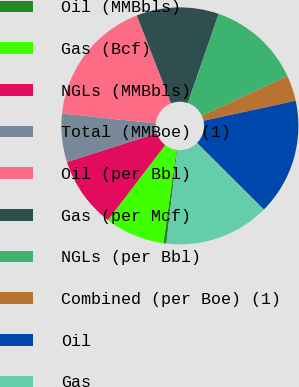<chart> <loc_0><loc_0><loc_500><loc_500><pie_chart><fcel>Oil (MMBbls)<fcel>Gas (Bcf)<fcel>NGLs (MMBbls)<fcel>Total (MMBoe) (1)<fcel>Oil (per Bbl)<fcel>Gas (per Mcf)<fcel>NGLs (per Bbl)<fcel>Combined (per Boe) (1)<fcel>Oil<fcel>Gas<nl><fcel>0.42%<fcel>8.15%<fcel>9.69%<fcel>6.6%<fcel>17.41%<fcel>11.24%<fcel>12.78%<fcel>3.51%<fcel>15.87%<fcel>14.33%<nl></chart> 